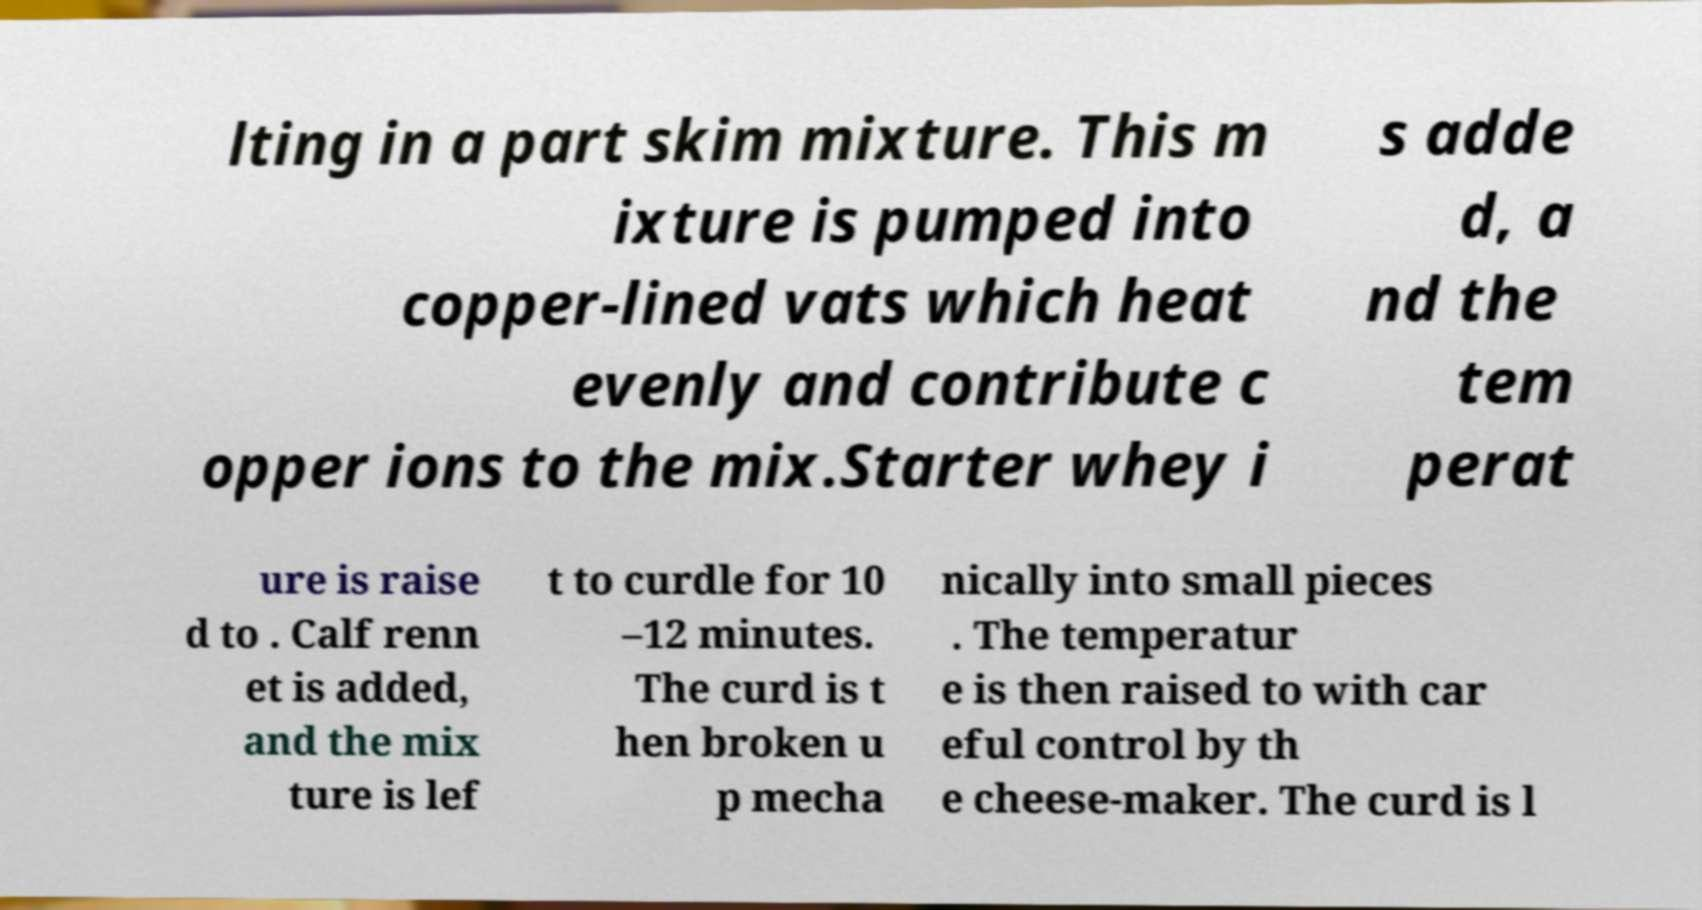Please read and relay the text visible in this image. What does it say? lting in a part skim mixture. This m ixture is pumped into copper-lined vats which heat evenly and contribute c opper ions to the mix.Starter whey i s adde d, a nd the tem perat ure is raise d to . Calf renn et is added, and the mix ture is lef t to curdle for 10 –12 minutes. The curd is t hen broken u p mecha nically into small pieces . The temperatur e is then raised to with car eful control by th e cheese-maker. The curd is l 